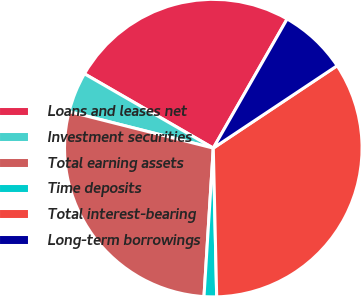Convert chart. <chart><loc_0><loc_0><loc_500><loc_500><pie_chart><fcel>Loans and leases net<fcel>Investment securities<fcel>Total earning assets<fcel>Time deposits<fcel>Total interest-bearing<fcel>Long-term borrowings<nl><fcel>24.94%<fcel>4.38%<fcel>27.95%<fcel>1.36%<fcel>33.98%<fcel>7.39%<nl></chart> 